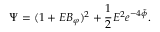Convert formula to latex. <formula><loc_0><loc_0><loc_500><loc_500>\Psi = ( 1 + E B _ { \varphi } ) ^ { 2 } + \frac { 1 } { 2 } E ^ { 2 } e ^ { - 4 \tilde { \phi } } .</formula> 